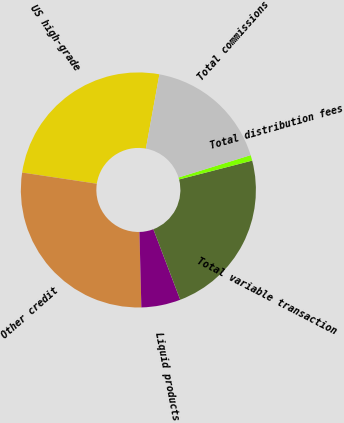Convert chart. <chart><loc_0><loc_0><loc_500><loc_500><pie_chart><fcel>US high-grade<fcel>Other credit<fcel>Liquid products<fcel>Total variable transaction<fcel>Total distribution fees<fcel>Total commissions<nl><fcel>25.5%<fcel>27.77%<fcel>5.39%<fcel>23.22%<fcel>0.77%<fcel>17.35%<nl></chart> 